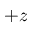<formula> <loc_0><loc_0><loc_500><loc_500>+ z</formula> 